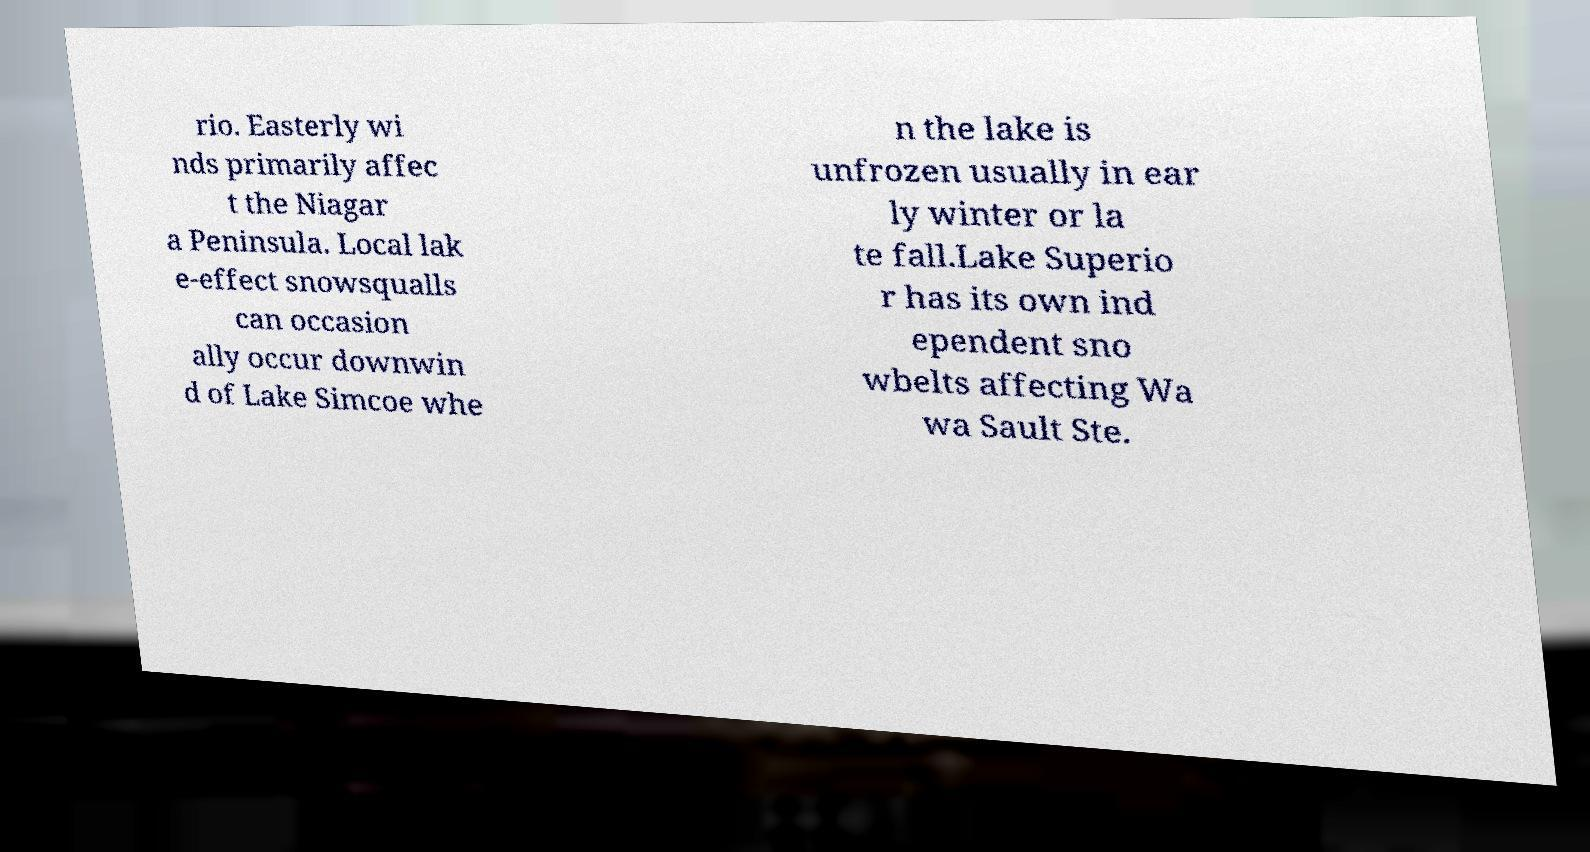There's text embedded in this image that I need extracted. Can you transcribe it verbatim? rio. Easterly wi nds primarily affec t the Niagar a Peninsula. Local lak e-effect snowsqualls can occasion ally occur downwin d of Lake Simcoe whe n the lake is unfrozen usually in ear ly winter or la te fall.Lake Superio r has its own ind ependent sno wbelts affecting Wa wa Sault Ste. 